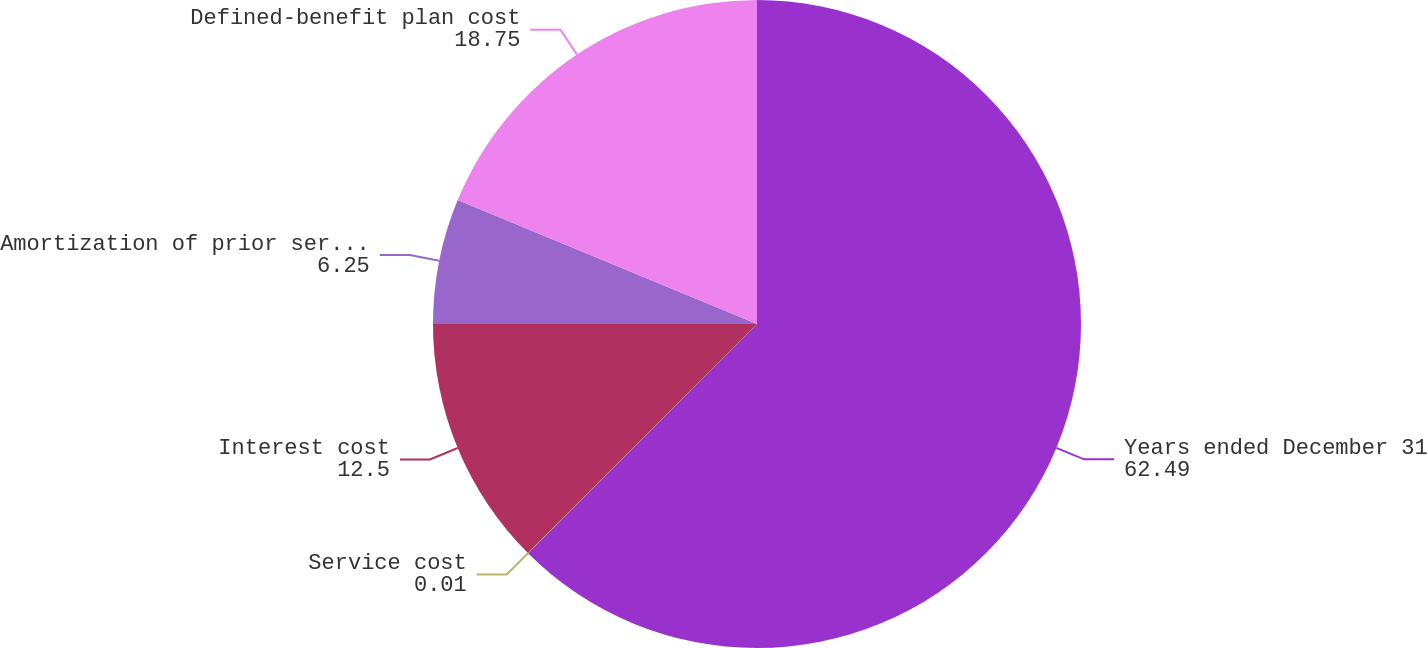Convert chart. <chart><loc_0><loc_0><loc_500><loc_500><pie_chart><fcel>Years ended December 31<fcel>Service cost<fcel>Interest cost<fcel>Amortization of prior service<fcel>Defined-benefit plan cost<nl><fcel>62.49%<fcel>0.01%<fcel>12.5%<fcel>6.25%<fcel>18.75%<nl></chart> 